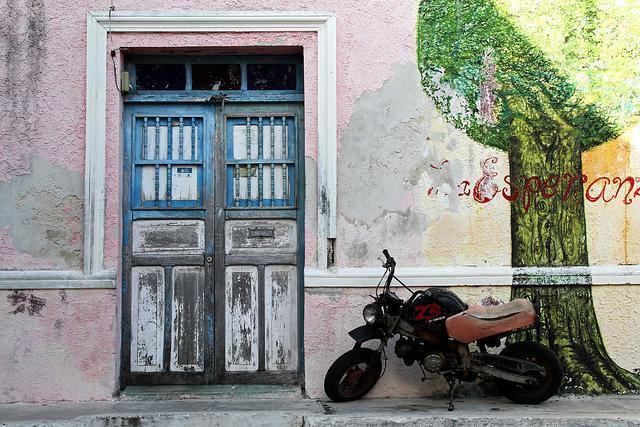How many people are wearing hat?
Give a very brief answer. 0. 